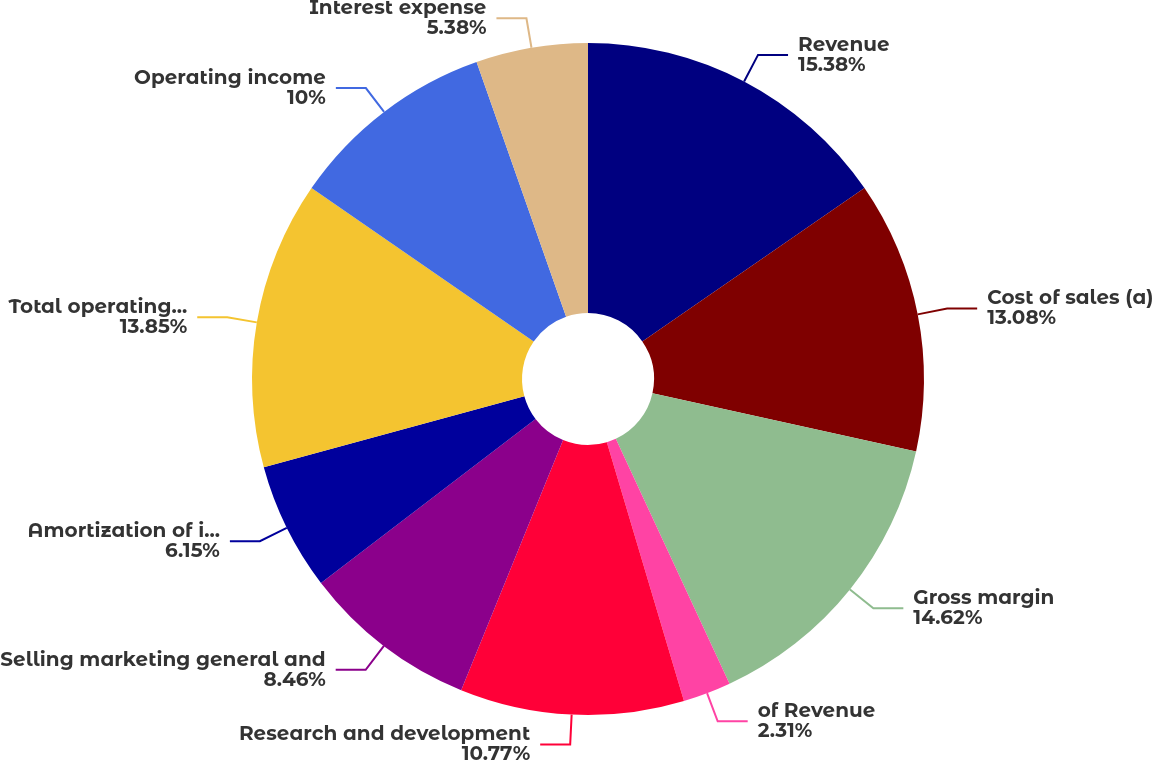<chart> <loc_0><loc_0><loc_500><loc_500><pie_chart><fcel>Revenue<fcel>Cost of sales (a)<fcel>Gross margin<fcel>of Revenue<fcel>Research and development<fcel>Selling marketing general and<fcel>Amortization of intangibles<fcel>Total operating expenses<fcel>Operating income<fcel>Interest expense<nl><fcel>15.38%<fcel>13.08%<fcel>14.62%<fcel>2.31%<fcel>10.77%<fcel>8.46%<fcel>6.15%<fcel>13.85%<fcel>10.0%<fcel>5.38%<nl></chart> 